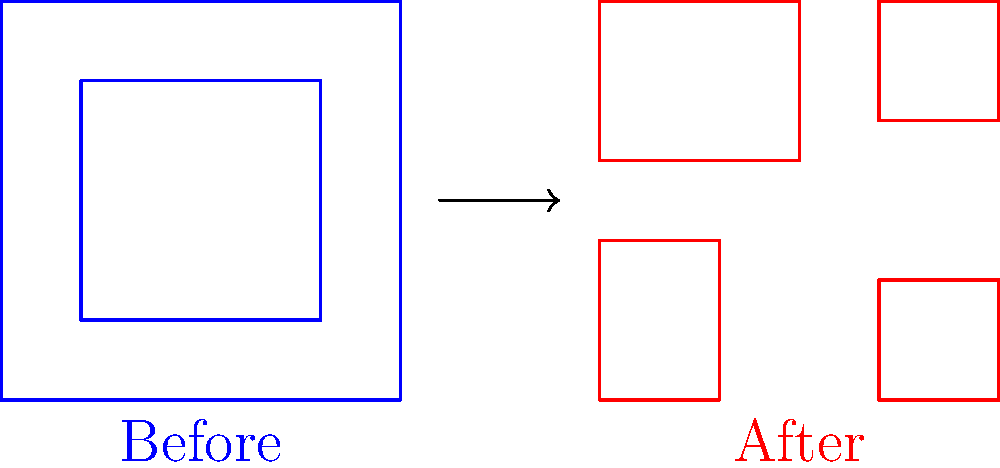In the context of urban topology changes due to aerial bombardment, what fundamental topological property is most significantly altered when comparing the "Before" and "After" scenarios in the diagram? To answer this question, let's analyze the topological changes step-by-step:

1. Before bombardment:
   - The urban area is represented by two connected shapes.
   - There is one large outer boundary and one inner boundary (hole).

2. After bombardment:
   - The urban area is fragmented into four disconnected shapes.
   - There are no inner boundaries (holes) in any of the fragments.

3. Topological properties to consider:
   a) Connectivity: The number of connected components.
   b) Holes: The presence or absence of inner boundaries.
   c) Boundaries: The nature of outer boundaries.

4. Key changes:
   - The most significant change is in connectivity.
   - The urban landscape went from one connected component to four disconnected components.
   - This change in connectivity is a fundamental topological property, as it alters the way different parts of the urban area relate to each other.

5. Other changes:
   - The disappearance of the inner hole is also a topological change, but less fundamental than the change in connectivity.
   - The outer boundary's shape has changed, but this is more of a geometric than a topological change.

Therefore, the most significantly altered fundamental topological property is connectivity.
Answer: Connectivity 